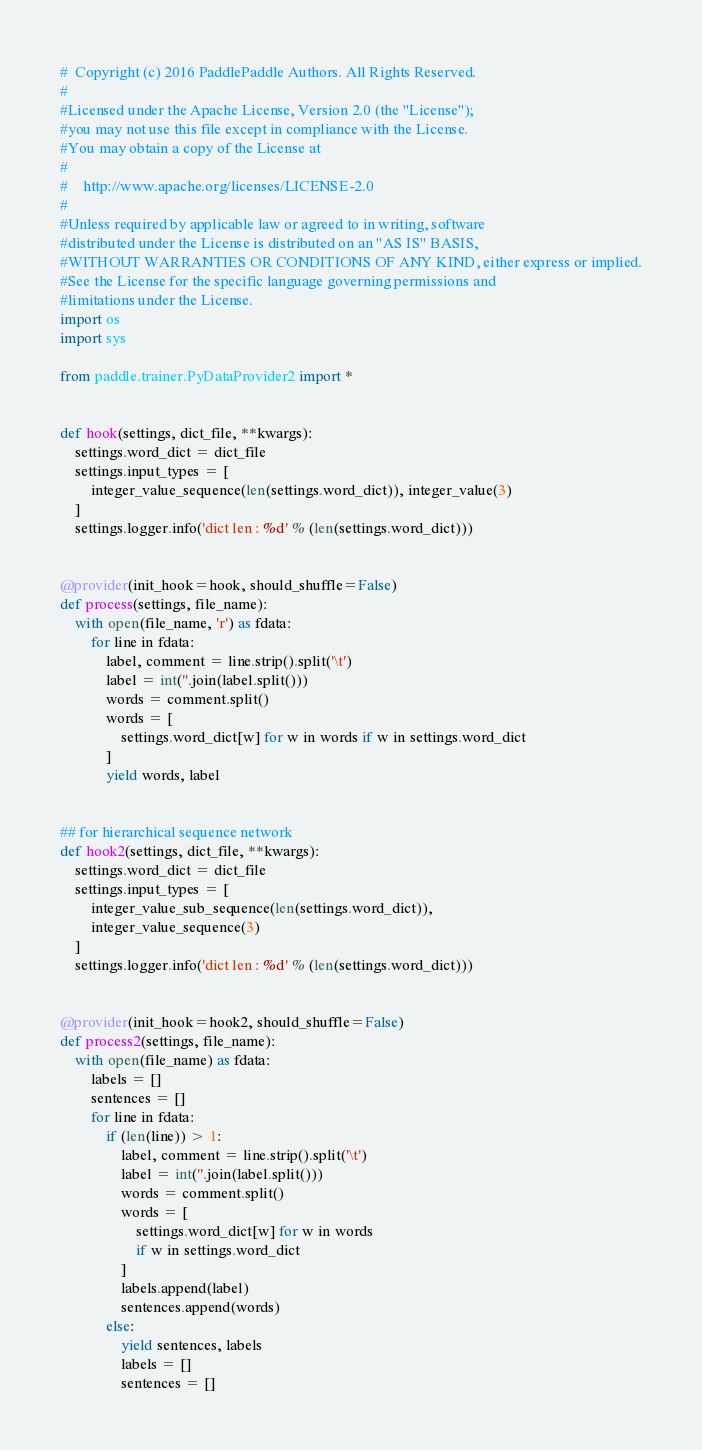<code> <loc_0><loc_0><loc_500><loc_500><_Python_>#  Copyright (c) 2016 PaddlePaddle Authors. All Rights Reserved.
#
#Licensed under the Apache License, Version 2.0 (the "License");
#you may not use this file except in compliance with the License.
#You may obtain a copy of the License at
#
#    http://www.apache.org/licenses/LICENSE-2.0
#
#Unless required by applicable law or agreed to in writing, software
#distributed under the License is distributed on an "AS IS" BASIS,
#WITHOUT WARRANTIES OR CONDITIONS OF ANY KIND, either express or implied.
#See the License for the specific language governing permissions and
#limitations under the License.
import os
import sys

from paddle.trainer.PyDataProvider2 import *


def hook(settings, dict_file, **kwargs):
    settings.word_dict = dict_file
    settings.input_types = [
        integer_value_sequence(len(settings.word_dict)), integer_value(3)
    ]
    settings.logger.info('dict len : %d' % (len(settings.word_dict)))


@provider(init_hook=hook, should_shuffle=False)
def process(settings, file_name):
    with open(file_name, 'r') as fdata:
        for line in fdata:
            label, comment = line.strip().split('\t')
            label = int(''.join(label.split()))
            words = comment.split()
            words = [
                settings.word_dict[w] for w in words if w in settings.word_dict
            ]
            yield words, label


## for hierarchical sequence network
def hook2(settings, dict_file, **kwargs):
    settings.word_dict = dict_file
    settings.input_types = [
        integer_value_sub_sequence(len(settings.word_dict)),
        integer_value_sequence(3)
    ]
    settings.logger.info('dict len : %d' % (len(settings.word_dict)))


@provider(init_hook=hook2, should_shuffle=False)
def process2(settings, file_name):
    with open(file_name) as fdata:
        labels = []
        sentences = []
        for line in fdata:
            if (len(line)) > 1:
                label, comment = line.strip().split('\t')
                label = int(''.join(label.split()))
                words = comment.split()
                words = [
                    settings.word_dict[w] for w in words
                    if w in settings.word_dict
                ]
                labels.append(label)
                sentences.append(words)
            else:
                yield sentences, labels
                labels = []
                sentences = []
</code> 